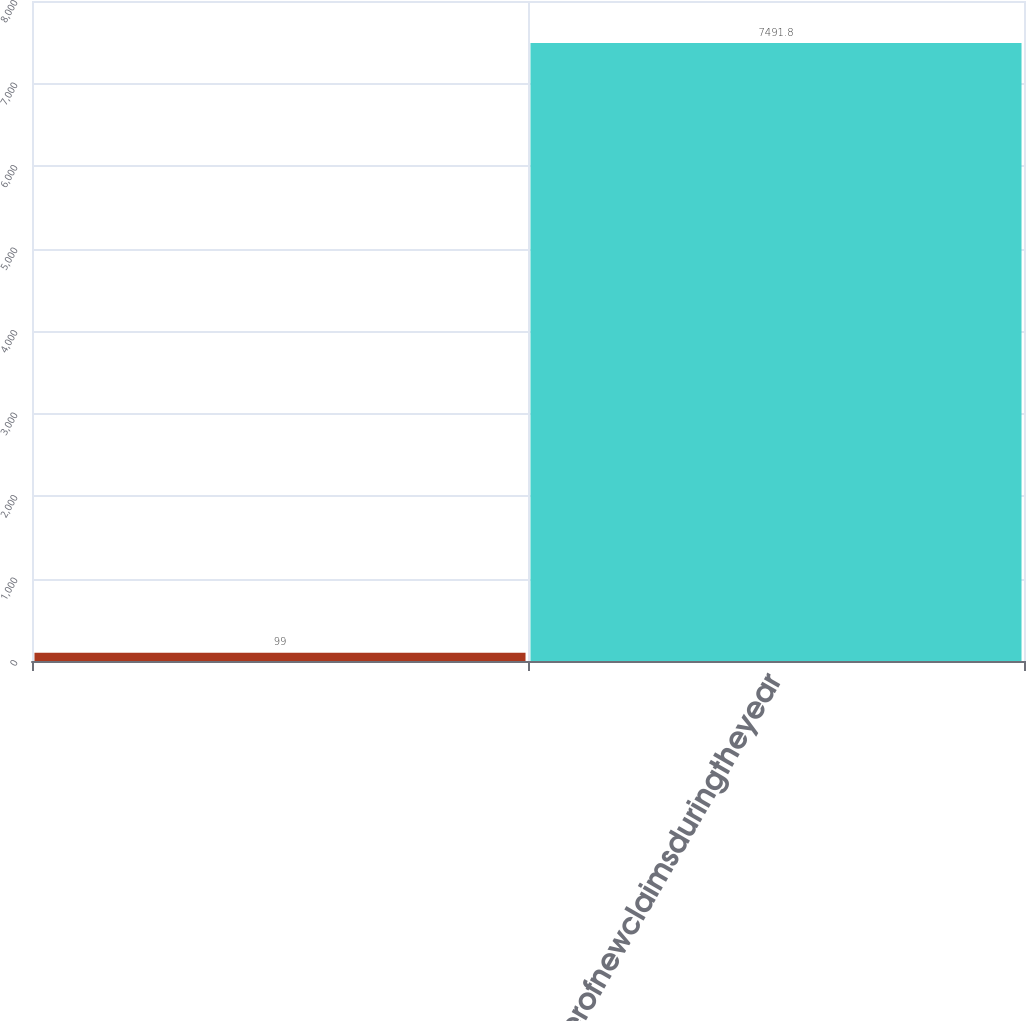<chart> <loc_0><loc_0><loc_500><loc_500><bar_chart><ecel><fcel>Numberofnewclaimsduringtheyear<nl><fcel>99<fcel>7491.8<nl></chart> 